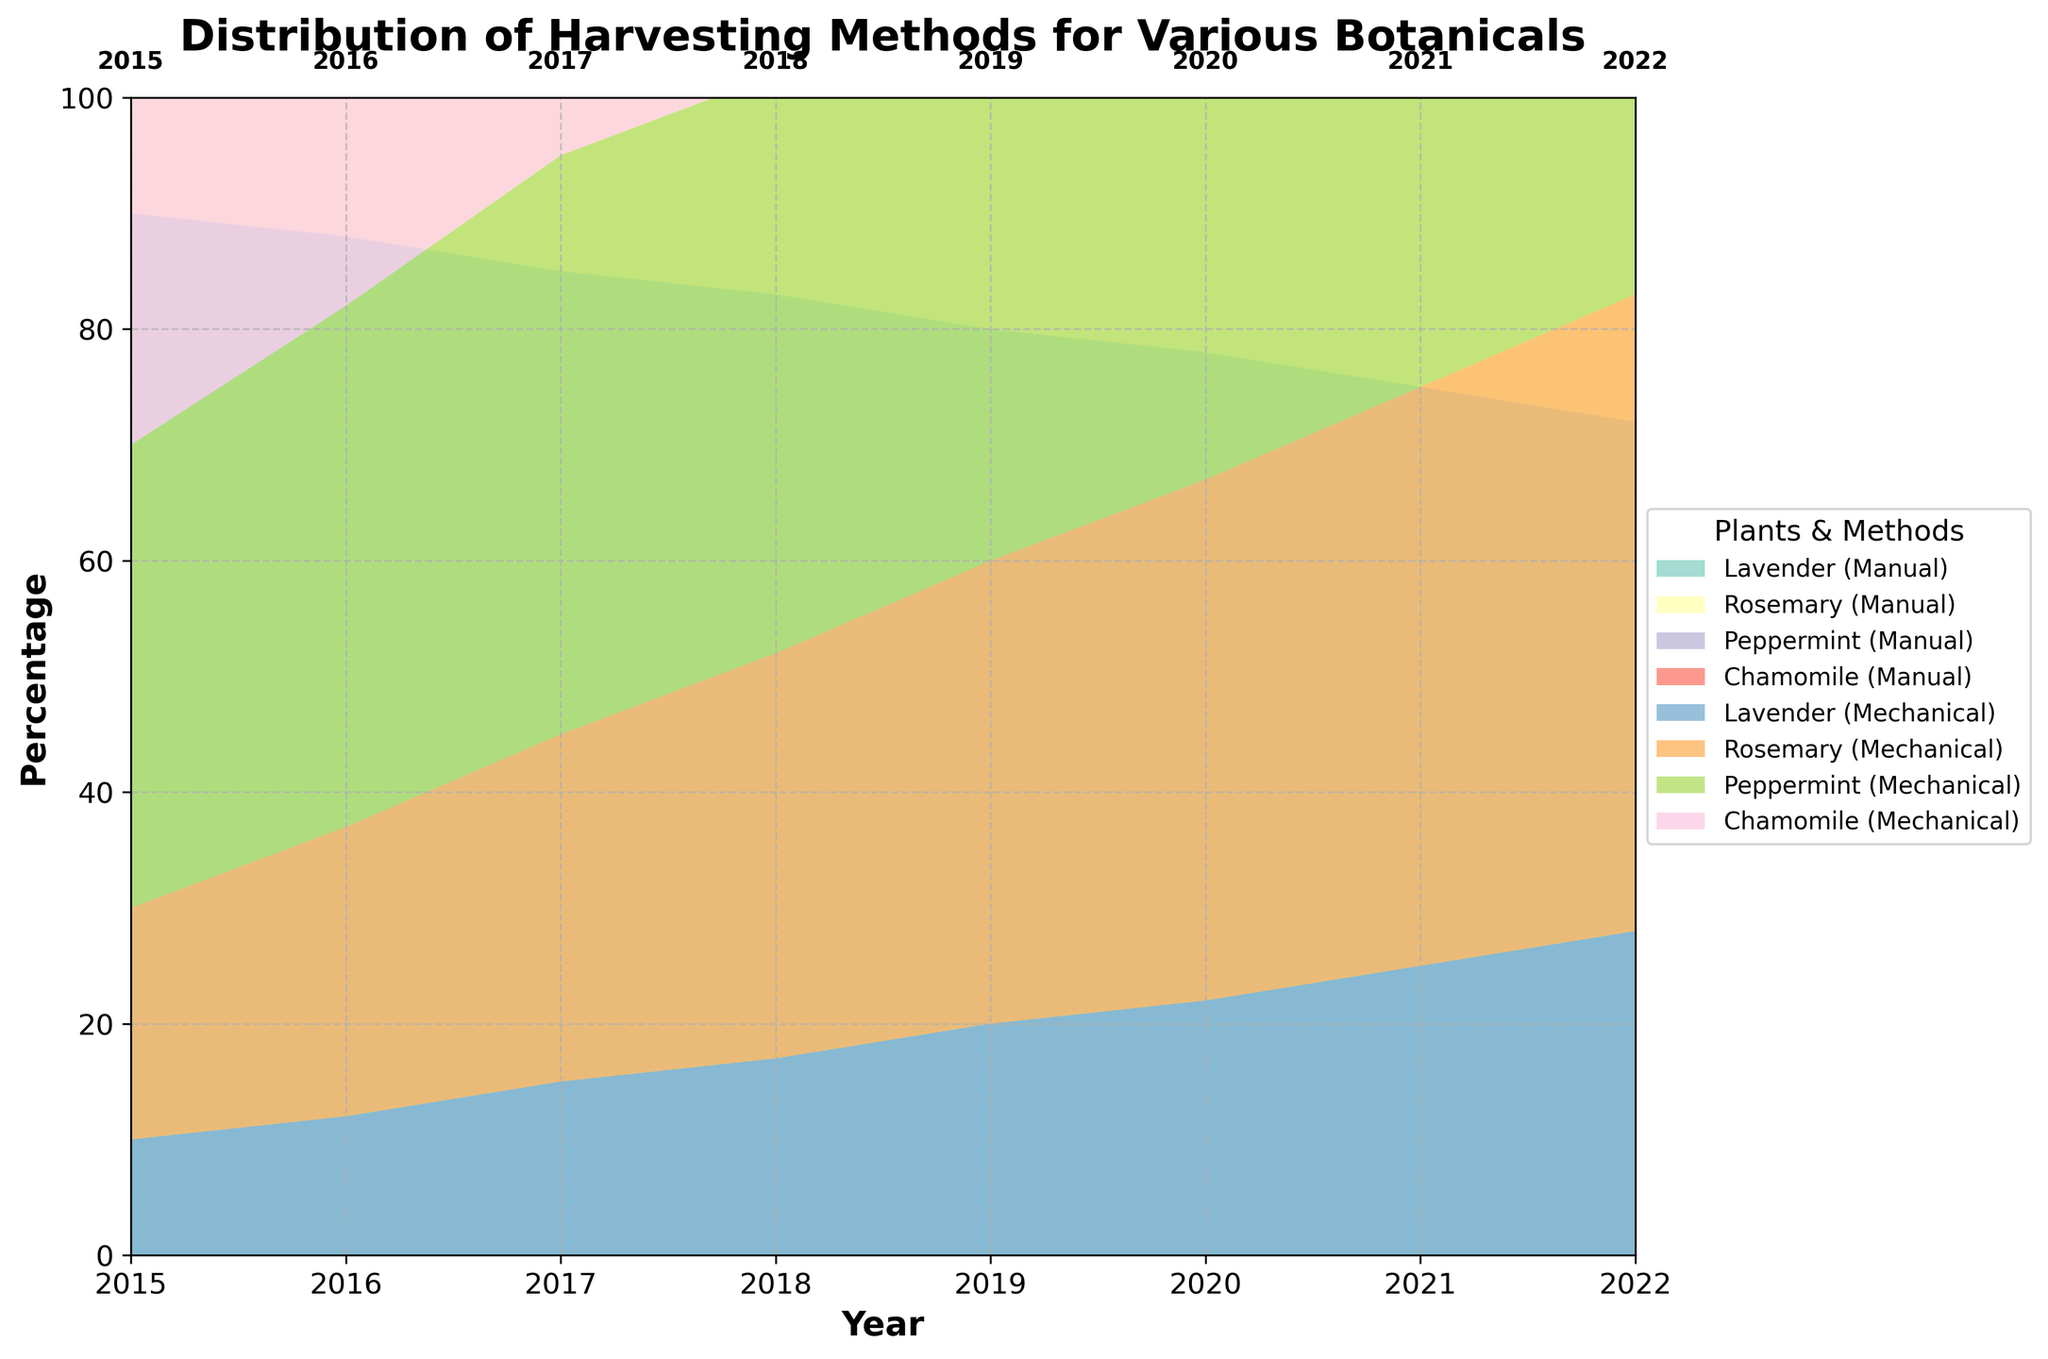What is the title of the chart? The title of the chart is located at the top of the figure, usually in a larger or bolder font than other text. It serves to inform the viewer about the subject of the chart.
Answer: Distribution of Harvesting Methods for Various Botanicals Which botanical had the highest percentage of manual harvesting in 2015? Look at the sections corresponding to the year 2015. Identify which colored segment representing manual harvesting is the tallest for that year.
Answer: Chamomile By how much did the percentage of manual harvesting for Lavender decrease from 2015 to 2022? Compare the height of the segments for manual harvesting of Lavender in 2015 and 2022 and calculate the difference.
Answer: 35% What trend can be observed for mechanical harvesting of Rosemary between 2015 and 2022? Observe the sections corresponding to mechanical harvesting of Rosemary from 2015 to 2022. Identify if the segments' height increased, decreased, or stayed constant over time.
Answer: Increasing trend In which year did Peppermint reach an equal distribution (50%) between manual and mechanical harvesting? Locate the year where the segments for manual and mechanical harvesting of Peppermint are equal in height, which should sum up to 100%.
Answer: 2017 Which botanical consistently had the highest manual harvesting percentage over the years? Compare the manual harvesting segments for each botanical across all years and identify which one is consistently the tallest.
Answer: Chamomile In 2022, which botanical had the highest mechanical harvesting percentage? Look at the sections corresponding to the year 2022 and identify which segment related to mechanical harvesting is the tallest.
Answer: Peppermint How did the manual harvesting percentage for Peppermint change from 2015 to 2016? Compare the height of the segments for manual harvesting of Peppermint between 2015 and 2016 and calculate the difference.
Answer: Decreased by 5% Overall, which harvesting method saw an increase across all botanicals from 2015 to 2022? Evaluate the segments for both manual and mechanical harvesting methods for all botanicals from 2015 to 2022. Identify which method's segments increased in height more frequently and consistently.
Answer: Mechanical 